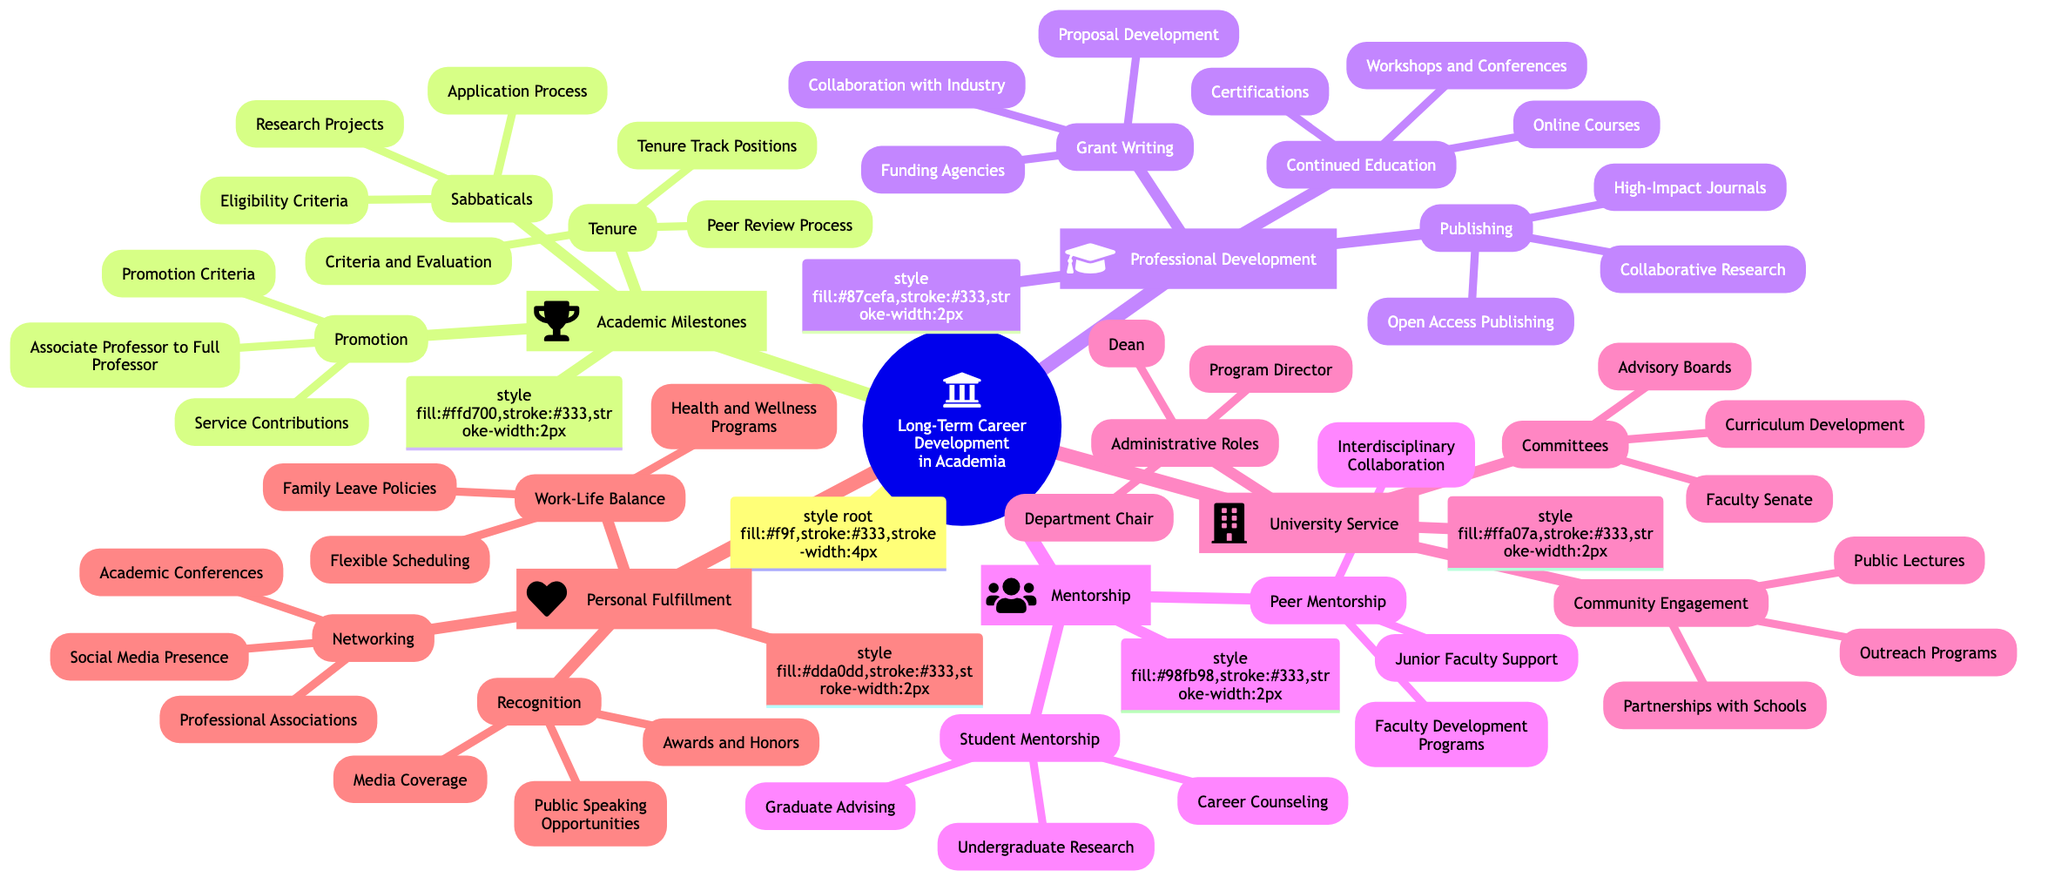What are the three key areas under Academic Milestones? The diagram lists "Tenure," "Promotion," and "Sabbaticals" as the three main branches under "Academic Milestones."
Answer: Tenure, Promotion, Sabbaticals How many topics fall under Professional Development? The "Professional Development" area contains three main topics: "Continued Education," "Publishing," and "Grant Writing."
Answer: 3 Which area includes the role of Department Chair? The role of "Department Chair" is part of the "Administrative Roles" subcategory, which is under the "University Service" branch.
Answer: University Service What are the three aspects of Personal Fulfillment? The three aspects listed under "Personal Fulfillment" are "Work-Life Balance," "Recognition," and "Networking."
Answer: Work-Life Balance, Recognition, Networking What type of mentorship involves Graduate Advising? Graduate Advising is a part of "Student Mentorship," which falls under the "Mentorship" category.
Answer: Student Mentorship How many roles are mentioned in the Administrative Roles section? The "Administrative Roles" section lists three specific roles: "Department Chair," "Program Director," and "Dean."
Answer: 3 What is one example of a topic under Continued Education? "Workshops and Conferences" is one of the topics listed under the "Continued Education" branch of "Professional Development."
Answer: Workshops and Conferences Which professional associations are mentioned under Networking? The specific professional associations highlighted are "AAUP" and "APSA," which are part of the "Networking" branch within "Personal Fulfillment."
Answer: AAUP, APSA What connects Faculty Development Programs to Mentorship? Faculty Development Programs are categorized under "Peer Mentorship," which is a part of the overarching "Mentorship" category.
Answer: Peer Mentorship 